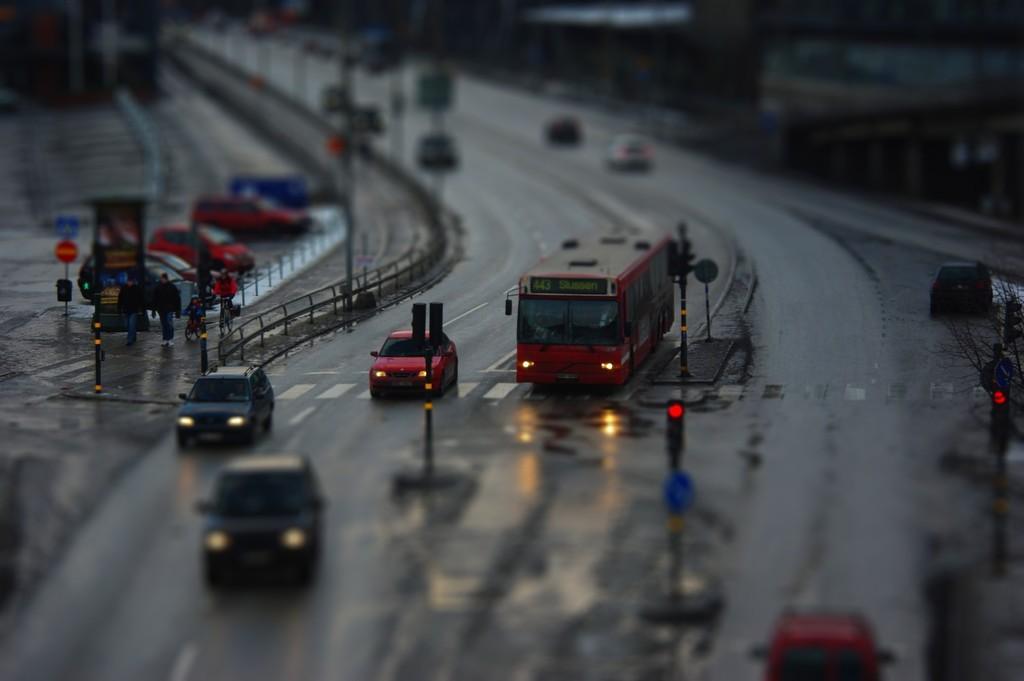How would you summarize this image in a sentence or two? It is a partial blur image, there is a road and there are few vehicles on the road, around the road there is a fencing, traffic signal poles and on the right side there is a tree. 